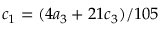<formula> <loc_0><loc_0><loc_500><loc_500>c _ { 1 } = ( 4 a _ { 3 } + 2 1 c _ { 3 } ) / 1 0 5</formula> 